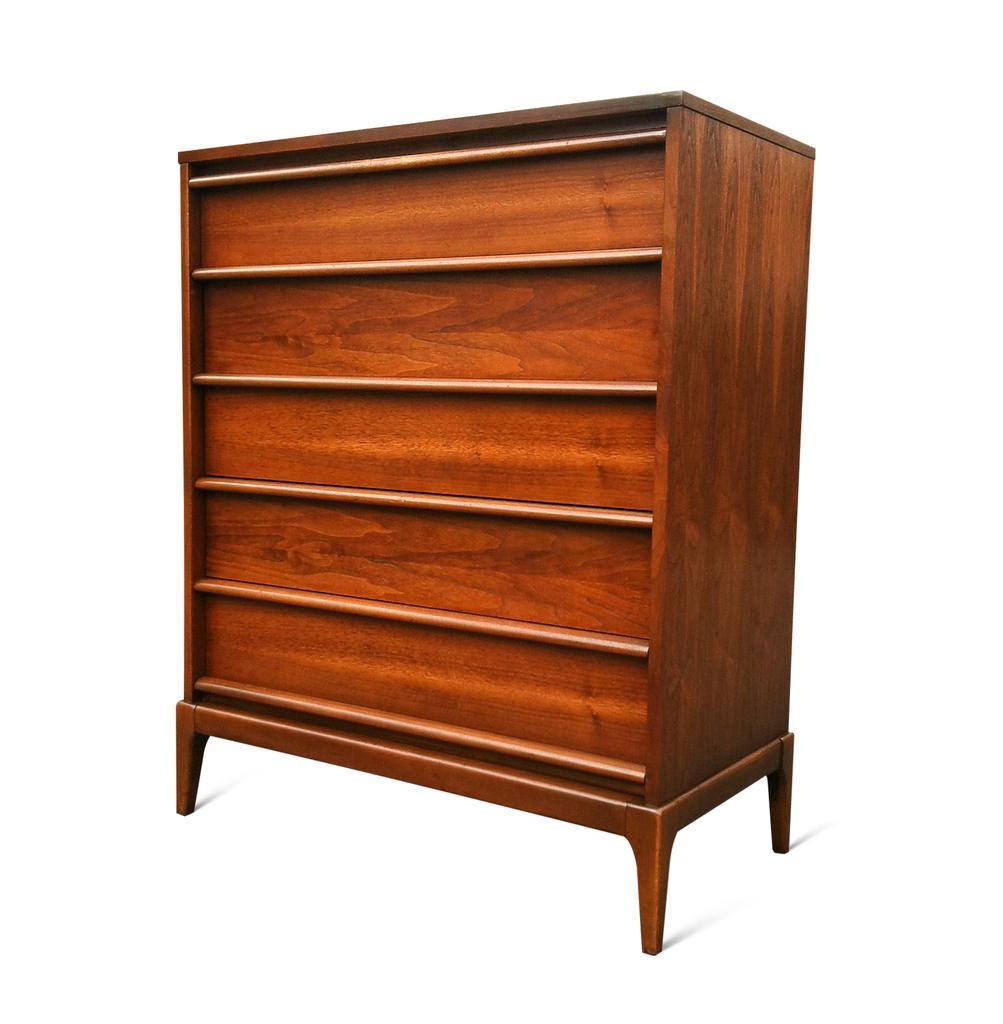Could you give a brief overview of what you see in this image? In this image there is a wooden cabinet. The background is white. 